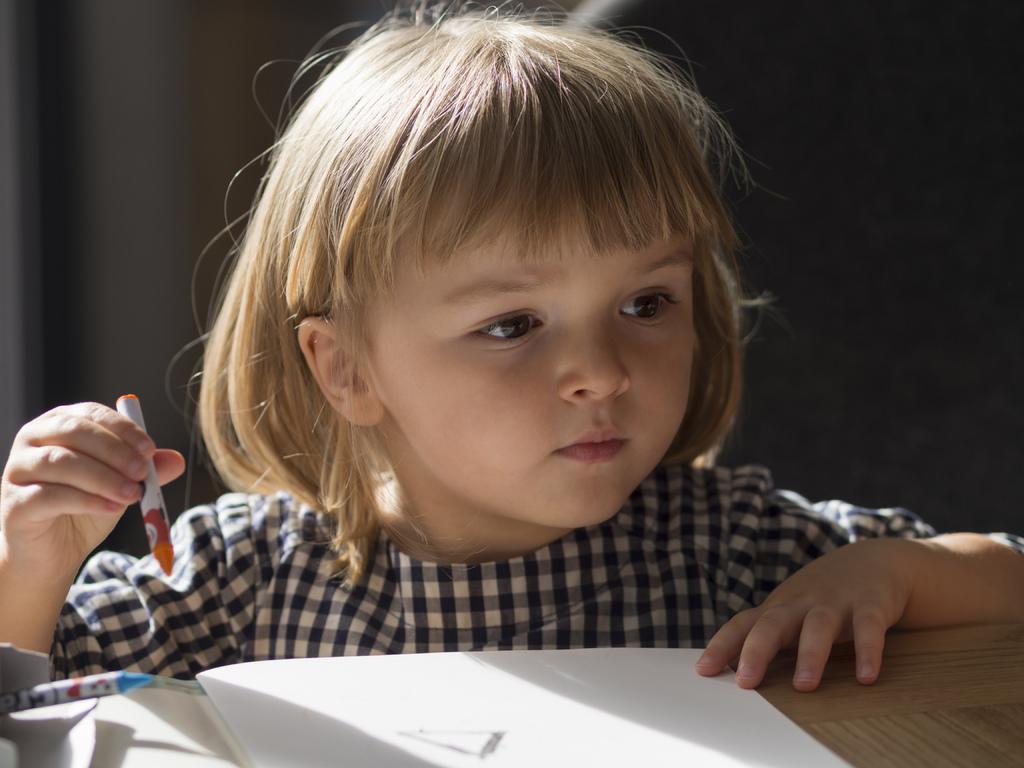Can you describe this image briefly? This image consists of a small girl is drawing in a book. She is wearing black and white dress. In front of her there is a table on which book is kept. 